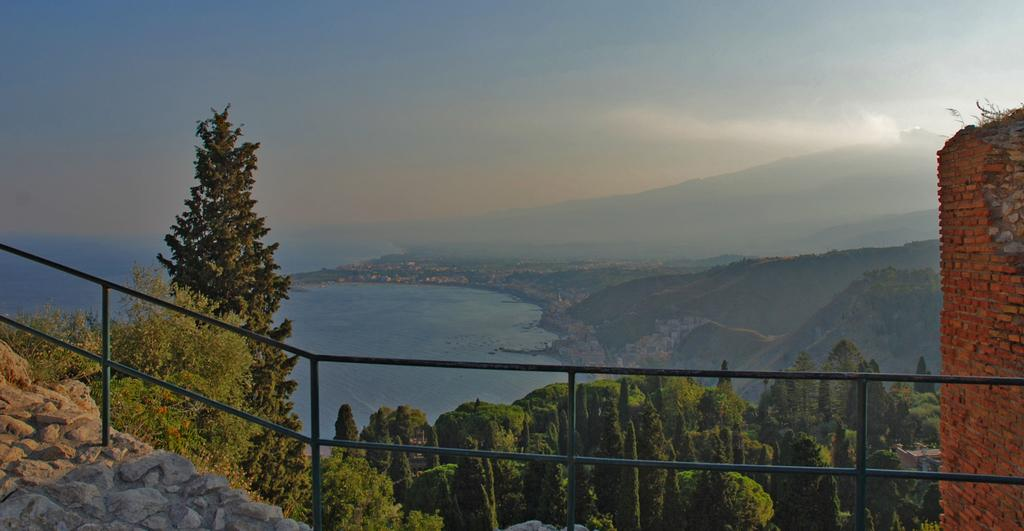What type of vegetation can be seen in the image? There are trees in the image. What type of barrier is present in the image? There is a fence in the image. What type of structure is on the right side of the image? There is a brick wall on the right side of the image. What can be seen in the background of the image? There is a water body, mountains, and the sky visible in the background of the image. Is there an umbrella being used by the carpenter in the image? There is no carpenter or umbrella present in the image. What type of woodworking tools can be seen in the image? There are no woodworking tools or carpenters present in the image. 